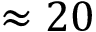<formula> <loc_0><loc_0><loc_500><loc_500>\approx 2 0</formula> 